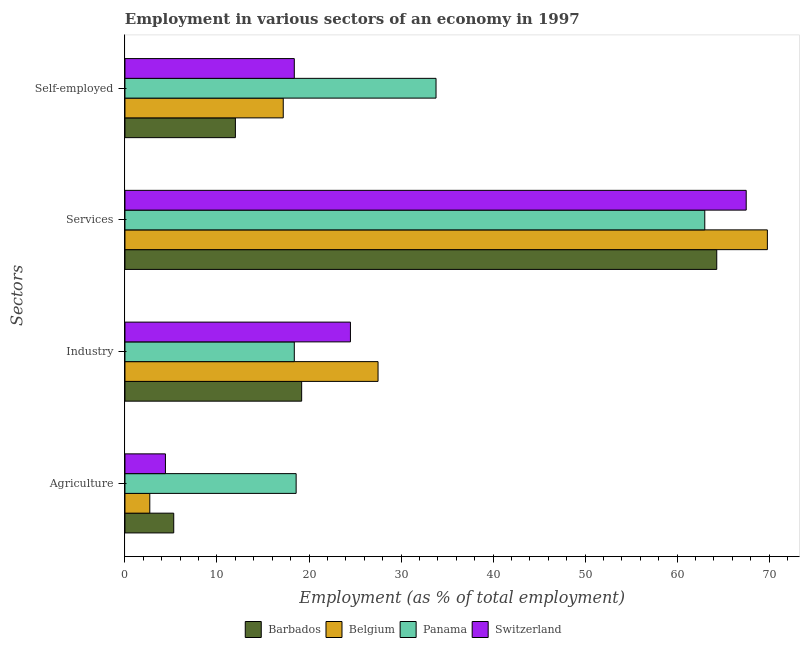How many different coloured bars are there?
Ensure brevity in your answer.  4. How many groups of bars are there?
Offer a very short reply. 4. Are the number of bars on each tick of the Y-axis equal?
Your answer should be very brief. Yes. What is the label of the 3rd group of bars from the top?
Give a very brief answer. Industry. What is the percentage of self employed workers in Belgium?
Your answer should be very brief. 17.2. Across all countries, what is the maximum percentage of workers in services?
Provide a succinct answer. 69.8. What is the total percentage of workers in agriculture in the graph?
Keep it short and to the point. 31. What is the difference between the percentage of workers in agriculture in Panama and that in Barbados?
Give a very brief answer. 13.3. What is the average percentage of workers in agriculture per country?
Your response must be concise. 7.75. What is the difference between the percentage of workers in services and percentage of self employed workers in Barbados?
Your answer should be very brief. 52.3. In how many countries, is the percentage of workers in agriculture greater than 2 %?
Provide a succinct answer. 4. What is the ratio of the percentage of self employed workers in Belgium to that in Panama?
Offer a terse response. 0.51. Is the percentage of workers in industry in Switzerland less than that in Belgium?
Make the answer very short. Yes. Is the difference between the percentage of workers in agriculture in Switzerland and Belgium greater than the difference between the percentage of self employed workers in Switzerland and Belgium?
Your answer should be compact. Yes. What is the difference between the highest and the second highest percentage of self employed workers?
Make the answer very short. 15.4. What is the difference between the highest and the lowest percentage of workers in agriculture?
Provide a succinct answer. 15.9. Is the sum of the percentage of workers in industry in Panama and Switzerland greater than the maximum percentage of self employed workers across all countries?
Provide a short and direct response. Yes. Is it the case that in every country, the sum of the percentage of self employed workers and percentage of workers in services is greater than the sum of percentage of workers in industry and percentage of workers in agriculture?
Provide a short and direct response. Yes. What does the 2nd bar from the top in Agriculture represents?
Offer a very short reply. Panama. What does the 3rd bar from the bottom in Self-employed represents?
Your response must be concise. Panama. Are the values on the major ticks of X-axis written in scientific E-notation?
Offer a terse response. No. Does the graph contain any zero values?
Keep it short and to the point. No. Does the graph contain grids?
Offer a terse response. No. How are the legend labels stacked?
Provide a succinct answer. Horizontal. What is the title of the graph?
Ensure brevity in your answer.  Employment in various sectors of an economy in 1997. Does "Uruguay" appear as one of the legend labels in the graph?
Give a very brief answer. No. What is the label or title of the X-axis?
Give a very brief answer. Employment (as % of total employment). What is the label or title of the Y-axis?
Provide a short and direct response. Sectors. What is the Employment (as % of total employment) of Barbados in Agriculture?
Provide a short and direct response. 5.3. What is the Employment (as % of total employment) in Belgium in Agriculture?
Ensure brevity in your answer.  2.7. What is the Employment (as % of total employment) in Panama in Agriculture?
Your answer should be very brief. 18.6. What is the Employment (as % of total employment) in Switzerland in Agriculture?
Offer a very short reply. 4.4. What is the Employment (as % of total employment) of Barbados in Industry?
Make the answer very short. 19.2. What is the Employment (as % of total employment) in Belgium in Industry?
Keep it short and to the point. 27.5. What is the Employment (as % of total employment) in Panama in Industry?
Make the answer very short. 18.4. What is the Employment (as % of total employment) of Switzerland in Industry?
Offer a very short reply. 24.5. What is the Employment (as % of total employment) in Barbados in Services?
Give a very brief answer. 64.3. What is the Employment (as % of total employment) in Belgium in Services?
Keep it short and to the point. 69.8. What is the Employment (as % of total employment) in Switzerland in Services?
Provide a short and direct response. 67.5. What is the Employment (as % of total employment) in Belgium in Self-employed?
Ensure brevity in your answer.  17.2. What is the Employment (as % of total employment) of Panama in Self-employed?
Keep it short and to the point. 33.8. What is the Employment (as % of total employment) in Switzerland in Self-employed?
Your answer should be compact. 18.4. Across all Sectors, what is the maximum Employment (as % of total employment) in Barbados?
Offer a very short reply. 64.3. Across all Sectors, what is the maximum Employment (as % of total employment) of Belgium?
Offer a very short reply. 69.8. Across all Sectors, what is the maximum Employment (as % of total employment) of Panama?
Give a very brief answer. 63. Across all Sectors, what is the maximum Employment (as % of total employment) of Switzerland?
Provide a short and direct response. 67.5. Across all Sectors, what is the minimum Employment (as % of total employment) of Barbados?
Provide a short and direct response. 5.3. Across all Sectors, what is the minimum Employment (as % of total employment) of Belgium?
Your answer should be very brief. 2.7. Across all Sectors, what is the minimum Employment (as % of total employment) of Panama?
Make the answer very short. 18.4. Across all Sectors, what is the minimum Employment (as % of total employment) of Switzerland?
Provide a succinct answer. 4.4. What is the total Employment (as % of total employment) of Barbados in the graph?
Make the answer very short. 100.8. What is the total Employment (as % of total employment) in Belgium in the graph?
Provide a succinct answer. 117.2. What is the total Employment (as % of total employment) of Panama in the graph?
Your answer should be very brief. 133.8. What is the total Employment (as % of total employment) of Switzerland in the graph?
Provide a short and direct response. 114.8. What is the difference between the Employment (as % of total employment) of Belgium in Agriculture and that in Industry?
Provide a succinct answer. -24.8. What is the difference between the Employment (as % of total employment) in Switzerland in Agriculture and that in Industry?
Provide a succinct answer. -20.1. What is the difference between the Employment (as % of total employment) of Barbados in Agriculture and that in Services?
Your answer should be very brief. -59. What is the difference between the Employment (as % of total employment) in Belgium in Agriculture and that in Services?
Your answer should be compact. -67.1. What is the difference between the Employment (as % of total employment) in Panama in Agriculture and that in Services?
Keep it short and to the point. -44.4. What is the difference between the Employment (as % of total employment) in Switzerland in Agriculture and that in Services?
Your answer should be very brief. -63.1. What is the difference between the Employment (as % of total employment) in Barbados in Agriculture and that in Self-employed?
Offer a very short reply. -6.7. What is the difference between the Employment (as % of total employment) in Panama in Agriculture and that in Self-employed?
Keep it short and to the point. -15.2. What is the difference between the Employment (as % of total employment) in Switzerland in Agriculture and that in Self-employed?
Provide a short and direct response. -14. What is the difference between the Employment (as % of total employment) in Barbados in Industry and that in Services?
Provide a succinct answer. -45.1. What is the difference between the Employment (as % of total employment) in Belgium in Industry and that in Services?
Keep it short and to the point. -42.3. What is the difference between the Employment (as % of total employment) of Panama in Industry and that in Services?
Provide a short and direct response. -44.6. What is the difference between the Employment (as % of total employment) in Switzerland in Industry and that in Services?
Your answer should be very brief. -43. What is the difference between the Employment (as % of total employment) in Barbados in Industry and that in Self-employed?
Keep it short and to the point. 7.2. What is the difference between the Employment (as % of total employment) of Belgium in Industry and that in Self-employed?
Offer a terse response. 10.3. What is the difference between the Employment (as % of total employment) of Panama in Industry and that in Self-employed?
Provide a short and direct response. -15.4. What is the difference between the Employment (as % of total employment) in Barbados in Services and that in Self-employed?
Keep it short and to the point. 52.3. What is the difference between the Employment (as % of total employment) in Belgium in Services and that in Self-employed?
Keep it short and to the point. 52.6. What is the difference between the Employment (as % of total employment) in Panama in Services and that in Self-employed?
Keep it short and to the point. 29.2. What is the difference between the Employment (as % of total employment) in Switzerland in Services and that in Self-employed?
Keep it short and to the point. 49.1. What is the difference between the Employment (as % of total employment) in Barbados in Agriculture and the Employment (as % of total employment) in Belgium in Industry?
Make the answer very short. -22.2. What is the difference between the Employment (as % of total employment) of Barbados in Agriculture and the Employment (as % of total employment) of Switzerland in Industry?
Your answer should be compact. -19.2. What is the difference between the Employment (as % of total employment) of Belgium in Agriculture and the Employment (as % of total employment) of Panama in Industry?
Your answer should be very brief. -15.7. What is the difference between the Employment (as % of total employment) in Belgium in Agriculture and the Employment (as % of total employment) in Switzerland in Industry?
Keep it short and to the point. -21.8. What is the difference between the Employment (as % of total employment) in Panama in Agriculture and the Employment (as % of total employment) in Switzerland in Industry?
Your answer should be compact. -5.9. What is the difference between the Employment (as % of total employment) in Barbados in Agriculture and the Employment (as % of total employment) in Belgium in Services?
Provide a short and direct response. -64.5. What is the difference between the Employment (as % of total employment) of Barbados in Agriculture and the Employment (as % of total employment) of Panama in Services?
Offer a very short reply. -57.7. What is the difference between the Employment (as % of total employment) of Barbados in Agriculture and the Employment (as % of total employment) of Switzerland in Services?
Your response must be concise. -62.2. What is the difference between the Employment (as % of total employment) in Belgium in Agriculture and the Employment (as % of total employment) in Panama in Services?
Provide a succinct answer. -60.3. What is the difference between the Employment (as % of total employment) in Belgium in Agriculture and the Employment (as % of total employment) in Switzerland in Services?
Your response must be concise. -64.8. What is the difference between the Employment (as % of total employment) in Panama in Agriculture and the Employment (as % of total employment) in Switzerland in Services?
Your answer should be compact. -48.9. What is the difference between the Employment (as % of total employment) of Barbados in Agriculture and the Employment (as % of total employment) of Belgium in Self-employed?
Provide a succinct answer. -11.9. What is the difference between the Employment (as % of total employment) in Barbados in Agriculture and the Employment (as % of total employment) in Panama in Self-employed?
Offer a terse response. -28.5. What is the difference between the Employment (as % of total employment) in Belgium in Agriculture and the Employment (as % of total employment) in Panama in Self-employed?
Your answer should be very brief. -31.1. What is the difference between the Employment (as % of total employment) of Belgium in Agriculture and the Employment (as % of total employment) of Switzerland in Self-employed?
Your response must be concise. -15.7. What is the difference between the Employment (as % of total employment) of Panama in Agriculture and the Employment (as % of total employment) of Switzerland in Self-employed?
Give a very brief answer. 0.2. What is the difference between the Employment (as % of total employment) in Barbados in Industry and the Employment (as % of total employment) in Belgium in Services?
Offer a terse response. -50.6. What is the difference between the Employment (as % of total employment) of Barbados in Industry and the Employment (as % of total employment) of Panama in Services?
Provide a succinct answer. -43.8. What is the difference between the Employment (as % of total employment) in Barbados in Industry and the Employment (as % of total employment) in Switzerland in Services?
Give a very brief answer. -48.3. What is the difference between the Employment (as % of total employment) of Belgium in Industry and the Employment (as % of total employment) of Panama in Services?
Offer a terse response. -35.5. What is the difference between the Employment (as % of total employment) of Panama in Industry and the Employment (as % of total employment) of Switzerland in Services?
Make the answer very short. -49.1. What is the difference between the Employment (as % of total employment) of Barbados in Industry and the Employment (as % of total employment) of Belgium in Self-employed?
Provide a succinct answer. 2. What is the difference between the Employment (as % of total employment) in Barbados in Industry and the Employment (as % of total employment) in Panama in Self-employed?
Provide a short and direct response. -14.6. What is the difference between the Employment (as % of total employment) of Barbados in Industry and the Employment (as % of total employment) of Switzerland in Self-employed?
Keep it short and to the point. 0.8. What is the difference between the Employment (as % of total employment) in Panama in Industry and the Employment (as % of total employment) in Switzerland in Self-employed?
Ensure brevity in your answer.  0. What is the difference between the Employment (as % of total employment) in Barbados in Services and the Employment (as % of total employment) in Belgium in Self-employed?
Give a very brief answer. 47.1. What is the difference between the Employment (as % of total employment) in Barbados in Services and the Employment (as % of total employment) in Panama in Self-employed?
Your answer should be very brief. 30.5. What is the difference between the Employment (as % of total employment) in Barbados in Services and the Employment (as % of total employment) in Switzerland in Self-employed?
Offer a very short reply. 45.9. What is the difference between the Employment (as % of total employment) of Belgium in Services and the Employment (as % of total employment) of Panama in Self-employed?
Keep it short and to the point. 36. What is the difference between the Employment (as % of total employment) of Belgium in Services and the Employment (as % of total employment) of Switzerland in Self-employed?
Your response must be concise. 51.4. What is the difference between the Employment (as % of total employment) of Panama in Services and the Employment (as % of total employment) of Switzerland in Self-employed?
Provide a succinct answer. 44.6. What is the average Employment (as % of total employment) of Barbados per Sectors?
Your answer should be very brief. 25.2. What is the average Employment (as % of total employment) of Belgium per Sectors?
Provide a short and direct response. 29.3. What is the average Employment (as % of total employment) in Panama per Sectors?
Make the answer very short. 33.45. What is the average Employment (as % of total employment) in Switzerland per Sectors?
Provide a short and direct response. 28.7. What is the difference between the Employment (as % of total employment) of Barbados and Employment (as % of total employment) of Panama in Agriculture?
Make the answer very short. -13.3. What is the difference between the Employment (as % of total employment) of Barbados and Employment (as % of total employment) of Switzerland in Agriculture?
Provide a short and direct response. 0.9. What is the difference between the Employment (as % of total employment) of Belgium and Employment (as % of total employment) of Panama in Agriculture?
Ensure brevity in your answer.  -15.9. What is the difference between the Employment (as % of total employment) in Belgium and Employment (as % of total employment) in Switzerland in Agriculture?
Provide a short and direct response. -1.7. What is the difference between the Employment (as % of total employment) of Panama and Employment (as % of total employment) of Switzerland in Agriculture?
Your answer should be compact. 14.2. What is the difference between the Employment (as % of total employment) of Belgium and Employment (as % of total employment) of Panama in Industry?
Offer a terse response. 9.1. What is the difference between the Employment (as % of total employment) in Belgium and Employment (as % of total employment) in Switzerland in Industry?
Ensure brevity in your answer.  3. What is the difference between the Employment (as % of total employment) of Barbados and Employment (as % of total employment) of Belgium in Services?
Offer a terse response. -5.5. What is the difference between the Employment (as % of total employment) of Barbados and Employment (as % of total employment) of Switzerland in Services?
Your answer should be compact. -3.2. What is the difference between the Employment (as % of total employment) in Barbados and Employment (as % of total employment) in Panama in Self-employed?
Offer a very short reply. -21.8. What is the difference between the Employment (as % of total employment) in Barbados and Employment (as % of total employment) in Switzerland in Self-employed?
Your answer should be very brief. -6.4. What is the difference between the Employment (as % of total employment) in Belgium and Employment (as % of total employment) in Panama in Self-employed?
Ensure brevity in your answer.  -16.6. What is the ratio of the Employment (as % of total employment) of Barbados in Agriculture to that in Industry?
Your answer should be compact. 0.28. What is the ratio of the Employment (as % of total employment) in Belgium in Agriculture to that in Industry?
Provide a succinct answer. 0.1. What is the ratio of the Employment (as % of total employment) of Panama in Agriculture to that in Industry?
Your response must be concise. 1.01. What is the ratio of the Employment (as % of total employment) in Switzerland in Agriculture to that in Industry?
Your answer should be very brief. 0.18. What is the ratio of the Employment (as % of total employment) of Barbados in Agriculture to that in Services?
Keep it short and to the point. 0.08. What is the ratio of the Employment (as % of total employment) of Belgium in Agriculture to that in Services?
Give a very brief answer. 0.04. What is the ratio of the Employment (as % of total employment) of Panama in Agriculture to that in Services?
Your answer should be compact. 0.3. What is the ratio of the Employment (as % of total employment) of Switzerland in Agriculture to that in Services?
Make the answer very short. 0.07. What is the ratio of the Employment (as % of total employment) in Barbados in Agriculture to that in Self-employed?
Provide a short and direct response. 0.44. What is the ratio of the Employment (as % of total employment) of Belgium in Agriculture to that in Self-employed?
Provide a succinct answer. 0.16. What is the ratio of the Employment (as % of total employment) in Panama in Agriculture to that in Self-employed?
Your answer should be compact. 0.55. What is the ratio of the Employment (as % of total employment) of Switzerland in Agriculture to that in Self-employed?
Offer a very short reply. 0.24. What is the ratio of the Employment (as % of total employment) of Barbados in Industry to that in Services?
Offer a very short reply. 0.3. What is the ratio of the Employment (as % of total employment) in Belgium in Industry to that in Services?
Your response must be concise. 0.39. What is the ratio of the Employment (as % of total employment) of Panama in Industry to that in Services?
Provide a short and direct response. 0.29. What is the ratio of the Employment (as % of total employment) in Switzerland in Industry to that in Services?
Keep it short and to the point. 0.36. What is the ratio of the Employment (as % of total employment) of Barbados in Industry to that in Self-employed?
Give a very brief answer. 1.6. What is the ratio of the Employment (as % of total employment) in Belgium in Industry to that in Self-employed?
Your answer should be very brief. 1.6. What is the ratio of the Employment (as % of total employment) of Panama in Industry to that in Self-employed?
Offer a very short reply. 0.54. What is the ratio of the Employment (as % of total employment) in Switzerland in Industry to that in Self-employed?
Ensure brevity in your answer.  1.33. What is the ratio of the Employment (as % of total employment) of Barbados in Services to that in Self-employed?
Ensure brevity in your answer.  5.36. What is the ratio of the Employment (as % of total employment) in Belgium in Services to that in Self-employed?
Your answer should be compact. 4.06. What is the ratio of the Employment (as % of total employment) of Panama in Services to that in Self-employed?
Provide a succinct answer. 1.86. What is the ratio of the Employment (as % of total employment) of Switzerland in Services to that in Self-employed?
Ensure brevity in your answer.  3.67. What is the difference between the highest and the second highest Employment (as % of total employment) in Barbados?
Ensure brevity in your answer.  45.1. What is the difference between the highest and the second highest Employment (as % of total employment) of Belgium?
Offer a terse response. 42.3. What is the difference between the highest and the second highest Employment (as % of total employment) in Panama?
Make the answer very short. 29.2. What is the difference between the highest and the lowest Employment (as % of total employment) of Belgium?
Your response must be concise. 67.1. What is the difference between the highest and the lowest Employment (as % of total employment) in Panama?
Provide a short and direct response. 44.6. What is the difference between the highest and the lowest Employment (as % of total employment) in Switzerland?
Give a very brief answer. 63.1. 